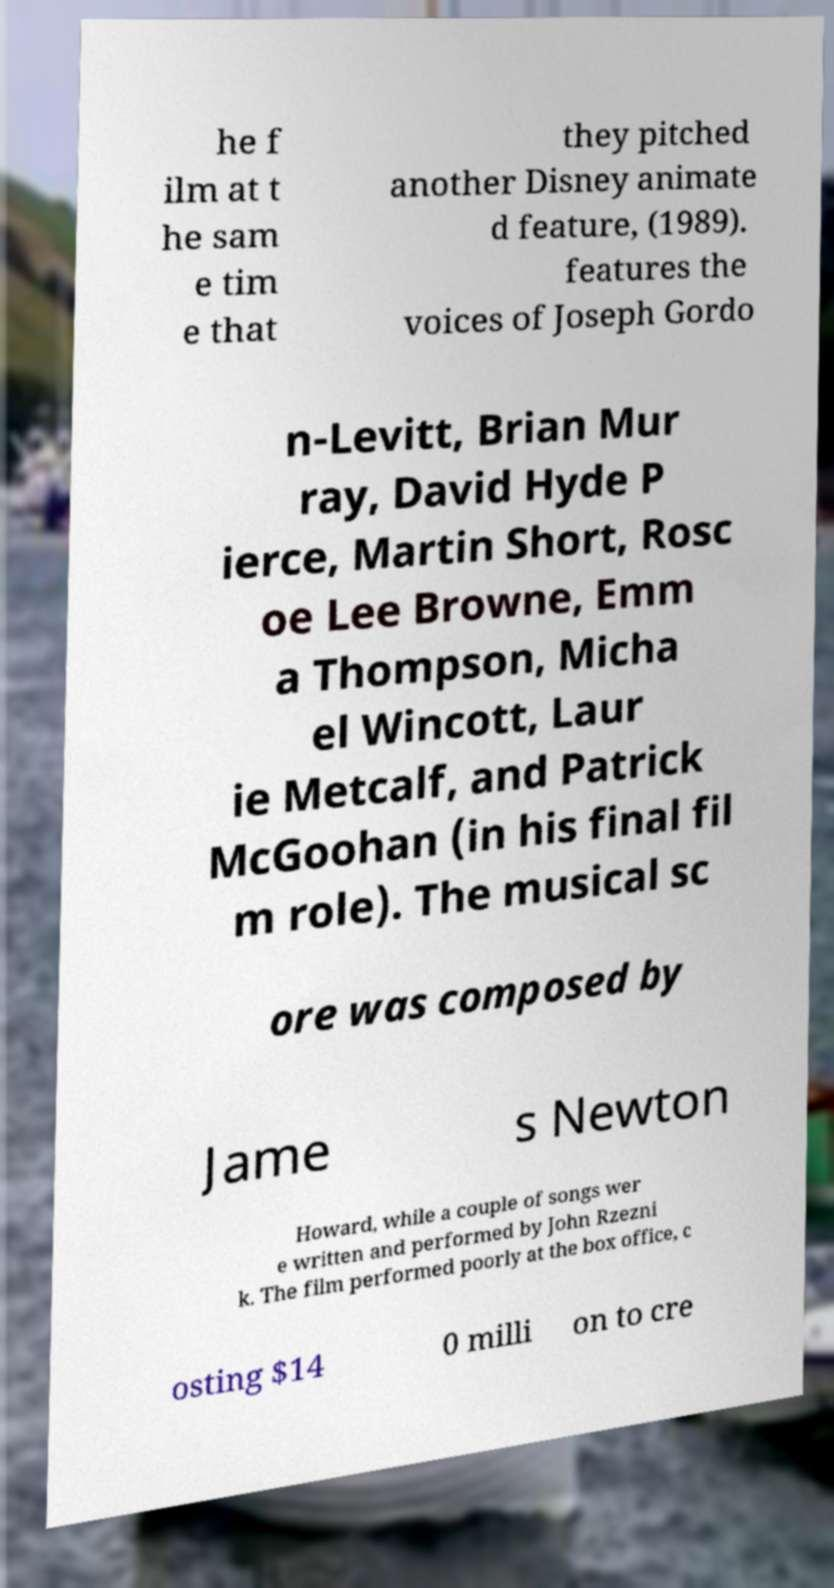What messages or text are displayed in this image? I need them in a readable, typed format. he f ilm at t he sam e tim e that they pitched another Disney animate d feature, (1989). features the voices of Joseph Gordo n-Levitt, Brian Mur ray, David Hyde P ierce, Martin Short, Rosc oe Lee Browne, Emm a Thompson, Micha el Wincott, Laur ie Metcalf, and Patrick McGoohan (in his final fil m role). The musical sc ore was composed by Jame s Newton Howard, while a couple of songs wer e written and performed by John Rzezni k. The film performed poorly at the box office, c osting $14 0 milli on to cre 